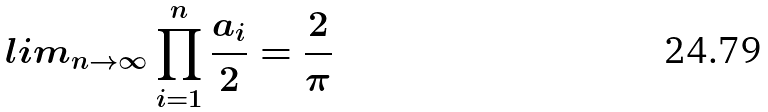<formula> <loc_0><loc_0><loc_500><loc_500>l i m _ { n \rightarrow \infty } \prod _ { i = 1 } ^ { n } \frac { a _ { i } } { 2 } = \frac { 2 } { \pi }</formula> 